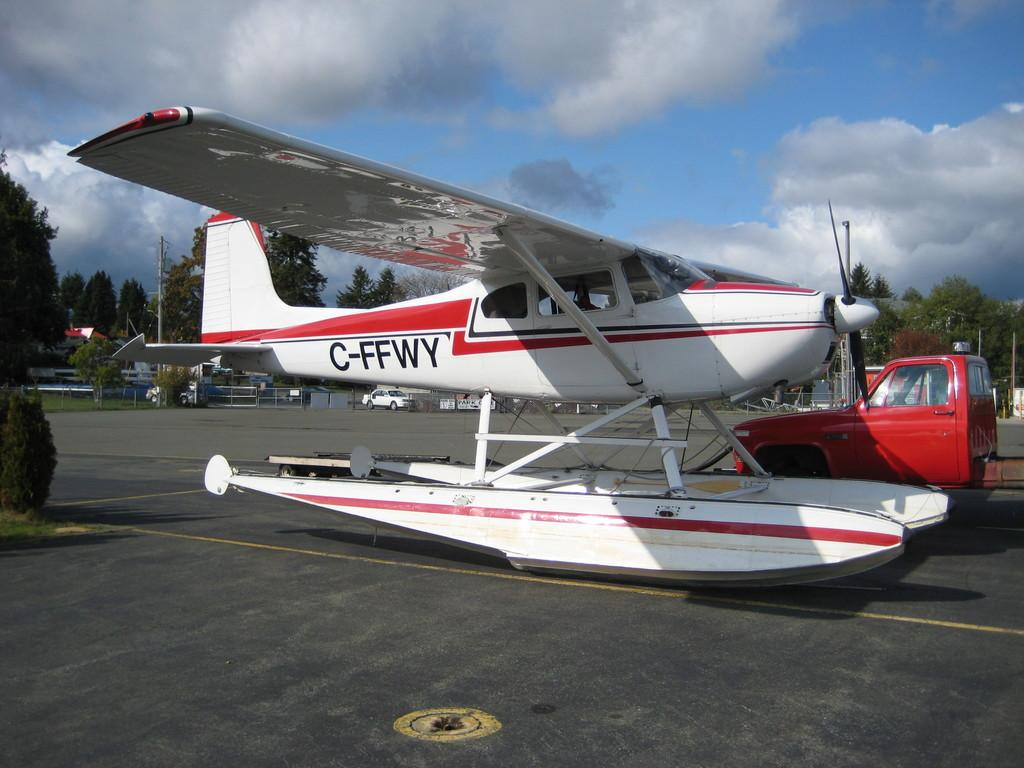What is the main subject of the image? The main subject of the image is an airplane. What else can be seen on the ground in the image? There are vehicles on the road in the image. What type of natural elements are present in the image? There are trees in the image. What man-made structures can be seen in the image? There are poles and railing in the image. What is visible in the background of the image? The sky is visible in the background of the image, and clouds are present in the sky. What type of cracker is being used to make the airplane fly in the image? There is no cracker present in the image, and the airplane is not flying; it is stationary on the ground. 